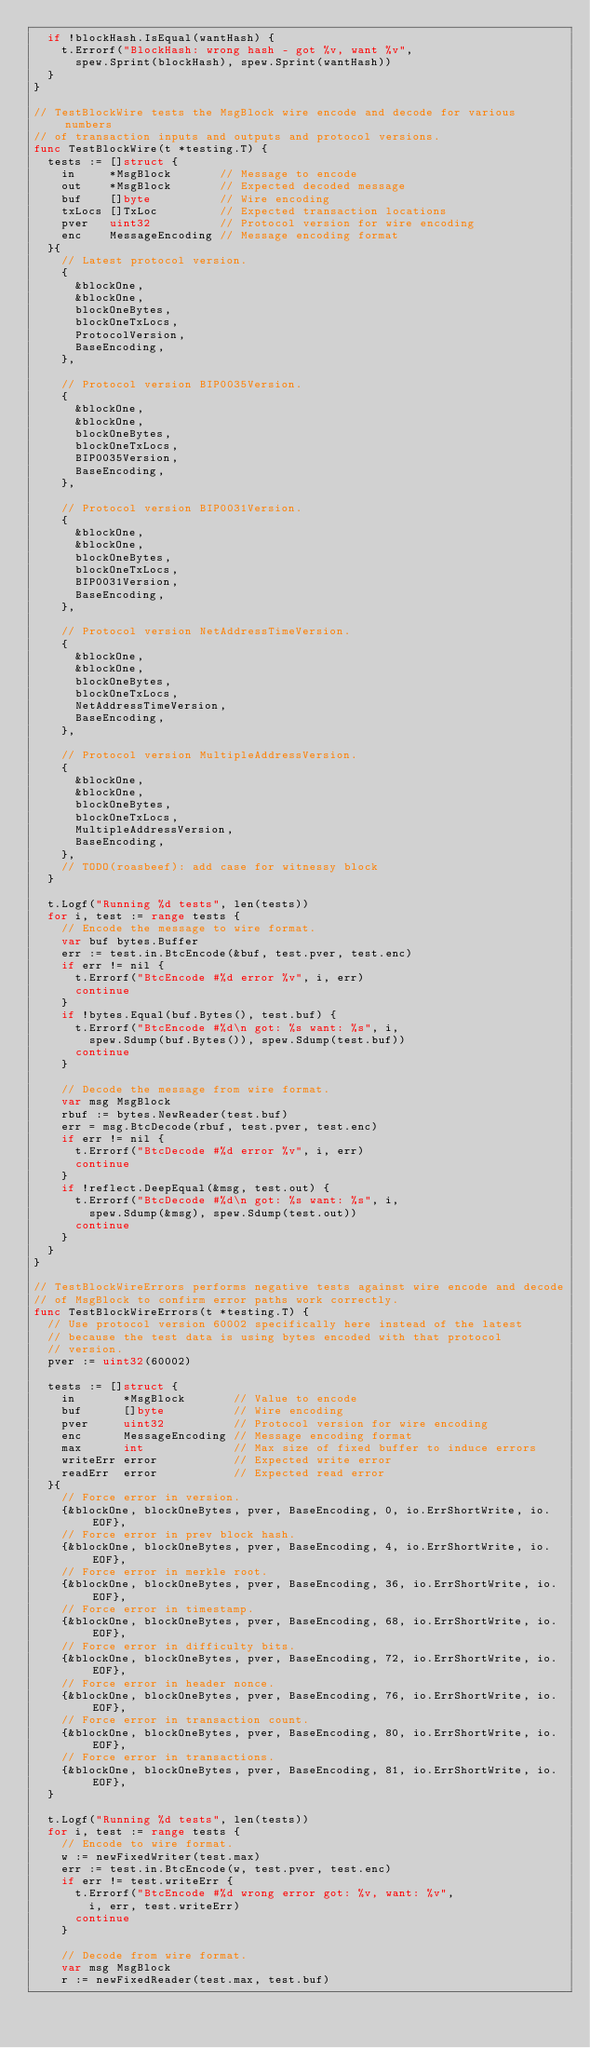Convert code to text. <code><loc_0><loc_0><loc_500><loc_500><_Go_>	if !blockHash.IsEqual(wantHash) {
		t.Errorf("BlockHash: wrong hash - got %v, want %v",
			spew.Sprint(blockHash), spew.Sprint(wantHash))
	}
}

// TestBlockWire tests the MsgBlock wire encode and decode for various numbers
// of transaction inputs and outputs and protocol versions.
func TestBlockWire(t *testing.T) {
	tests := []struct {
		in     *MsgBlock       // Message to encode
		out    *MsgBlock       // Expected decoded message
		buf    []byte          // Wire encoding
		txLocs []TxLoc         // Expected transaction locations
		pver   uint32          // Protocol version for wire encoding
		enc    MessageEncoding // Message encoding format
	}{
		// Latest protocol version.
		{
			&blockOne,
			&blockOne,
			blockOneBytes,
			blockOneTxLocs,
			ProtocolVersion,
			BaseEncoding,
		},

		// Protocol version BIP0035Version.
		{
			&blockOne,
			&blockOne,
			blockOneBytes,
			blockOneTxLocs,
			BIP0035Version,
			BaseEncoding,
		},

		// Protocol version BIP0031Version.
		{
			&blockOne,
			&blockOne,
			blockOneBytes,
			blockOneTxLocs,
			BIP0031Version,
			BaseEncoding,
		},

		// Protocol version NetAddressTimeVersion.
		{
			&blockOne,
			&blockOne,
			blockOneBytes,
			blockOneTxLocs,
			NetAddressTimeVersion,
			BaseEncoding,
		},

		// Protocol version MultipleAddressVersion.
		{
			&blockOne,
			&blockOne,
			blockOneBytes,
			blockOneTxLocs,
			MultipleAddressVersion,
			BaseEncoding,
		},
		// TODO(roasbeef): add case for witnessy block
	}

	t.Logf("Running %d tests", len(tests))
	for i, test := range tests {
		// Encode the message to wire format.
		var buf bytes.Buffer
		err := test.in.BtcEncode(&buf, test.pver, test.enc)
		if err != nil {
			t.Errorf("BtcEncode #%d error %v", i, err)
			continue
		}
		if !bytes.Equal(buf.Bytes(), test.buf) {
			t.Errorf("BtcEncode #%d\n got: %s want: %s", i,
				spew.Sdump(buf.Bytes()), spew.Sdump(test.buf))
			continue
		}

		// Decode the message from wire format.
		var msg MsgBlock
		rbuf := bytes.NewReader(test.buf)
		err = msg.BtcDecode(rbuf, test.pver, test.enc)
		if err != nil {
			t.Errorf("BtcDecode #%d error %v", i, err)
			continue
		}
		if !reflect.DeepEqual(&msg, test.out) {
			t.Errorf("BtcDecode #%d\n got: %s want: %s", i,
				spew.Sdump(&msg), spew.Sdump(test.out))
			continue
		}
	}
}

// TestBlockWireErrors performs negative tests against wire encode and decode
// of MsgBlock to confirm error paths work correctly.
func TestBlockWireErrors(t *testing.T) {
	// Use protocol version 60002 specifically here instead of the latest
	// because the test data is using bytes encoded with that protocol
	// version.
	pver := uint32(60002)

	tests := []struct {
		in       *MsgBlock       // Value to encode
		buf      []byte          // Wire encoding
		pver     uint32          // Protocol version for wire encoding
		enc      MessageEncoding // Message encoding format
		max      int             // Max size of fixed buffer to induce errors
		writeErr error           // Expected write error
		readErr  error           // Expected read error
	}{
		// Force error in version.
		{&blockOne, blockOneBytes, pver, BaseEncoding, 0, io.ErrShortWrite, io.EOF},
		// Force error in prev block hash.
		{&blockOne, blockOneBytes, pver, BaseEncoding, 4, io.ErrShortWrite, io.EOF},
		// Force error in merkle root.
		{&blockOne, blockOneBytes, pver, BaseEncoding, 36, io.ErrShortWrite, io.EOF},
		// Force error in timestamp.
		{&blockOne, blockOneBytes, pver, BaseEncoding, 68, io.ErrShortWrite, io.EOF},
		// Force error in difficulty bits.
		{&blockOne, blockOneBytes, pver, BaseEncoding, 72, io.ErrShortWrite, io.EOF},
		// Force error in header nonce.
		{&blockOne, blockOneBytes, pver, BaseEncoding, 76, io.ErrShortWrite, io.EOF},
		// Force error in transaction count.
		{&blockOne, blockOneBytes, pver, BaseEncoding, 80, io.ErrShortWrite, io.EOF},
		// Force error in transactions.
		{&blockOne, blockOneBytes, pver, BaseEncoding, 81, io.ErrShortWrite, io.EOF},
	}

	t.Logf("Running %d tests", len(tests))
	for i, test := range tests {
		// Encode to wire format.
		w := newFixedWriter(test.max)
		err := test.in.BtcEncode(w, test.pver, test.enc)
		if err != test.writeErr {
			t.Errorf("BtcEncode #%d wrong error got: %v, want: %v",
				i, err, test.writeErr)
			continue
		}

		// Decode from wire format.
		var msg MsgBlock
		r := newFixedReader(test.max, test.buf)</code> 